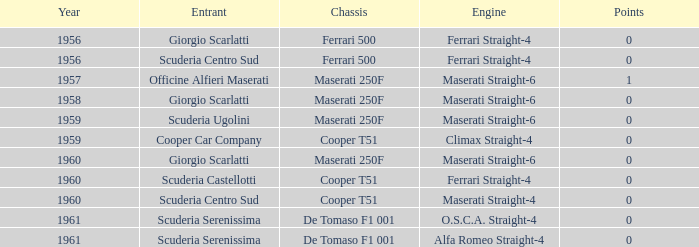What is the point tally for the cooper car company post 1959? None. 